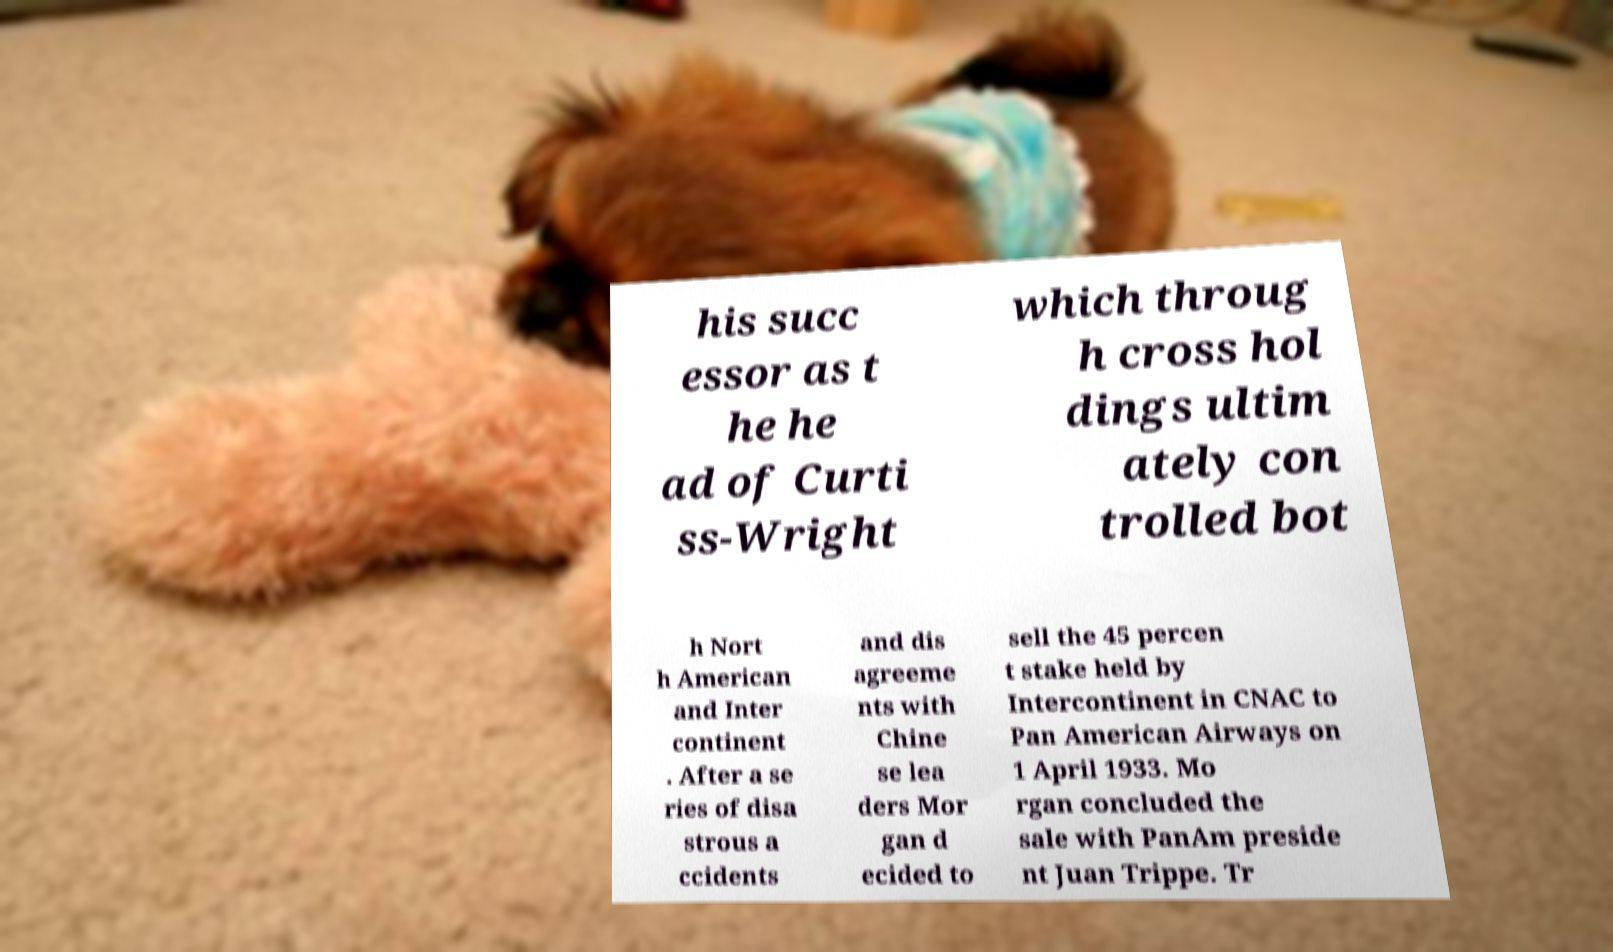For documentation purposes, I need the text within this image transcribed. Could you provide that? his succ essor as t he he ad of Curti ss-Wright which throug h cross hol dings ultim ately con trolled bot h Nort h American and Inter continent . After a se ries of disa strous a ccidents and dis agreeme nts with Chine se lea ders Mor gan d ecided to sell the 45 percen t stake held by Intercontinent in CNAC to Pan American Airways on 1 April 1933. Mo rgan concluded the sale with PanAm preside nt Juan Trippe. Tr 